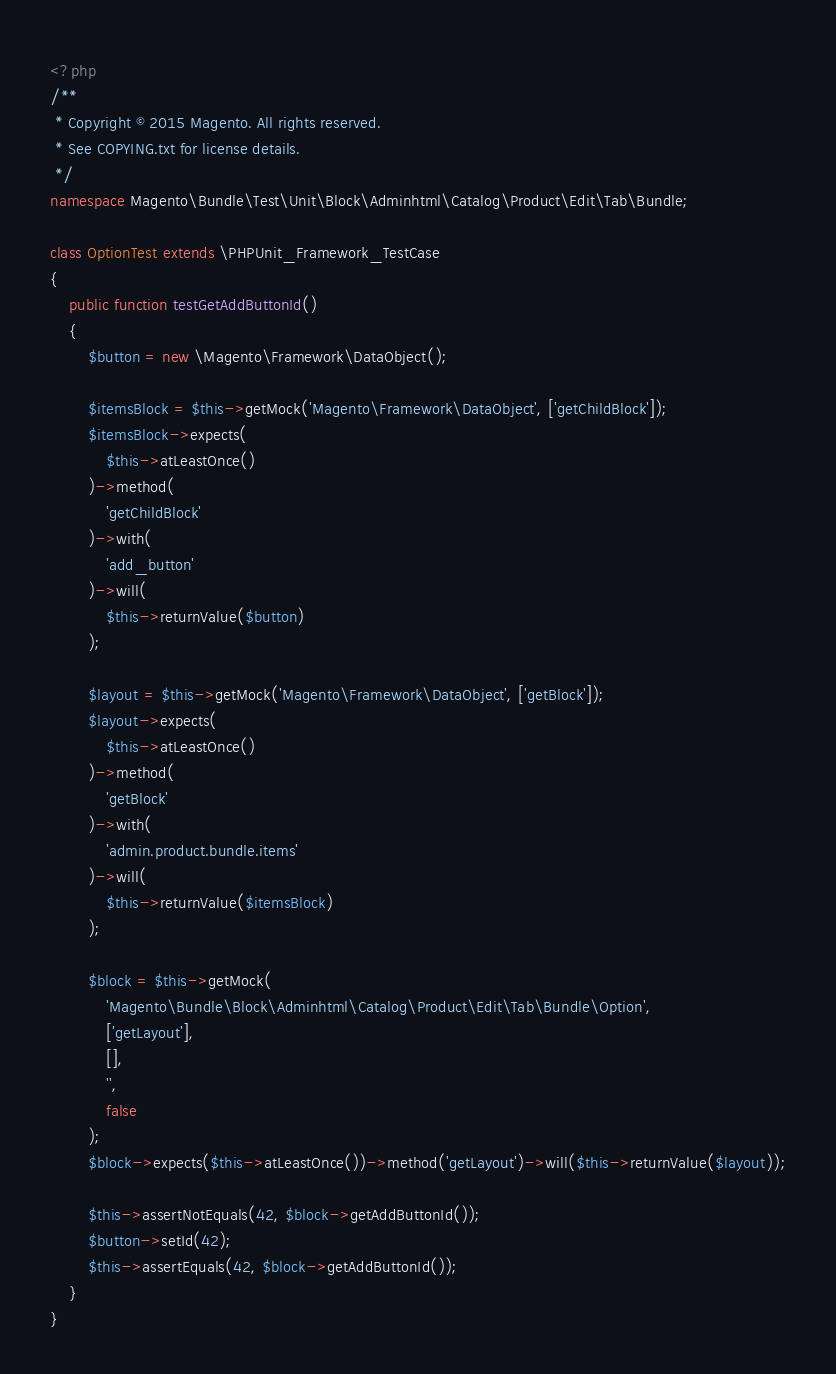Convert code to text. <code><loc_0><loc_0><loc_500><loc_500><_PHP_><?php
/**
 * Copyright © 2015 Magento. All rights reserved.
 * See COPYING.txt for license details.
 */
namespace Magento\Bundle\Test\Unit\Block\Adminhtml\Catalog\Product\Edit\Tab\Bundle;

class OptionTest extends \PHPUnit_Framework_TestCase
{
    public function testGetAddButtonId()
    {
        $button = new \Magento\Framework\DataObject();

        $itemsBlock = $this->getMock('Magento\Framework\DataObject', ['getChildBlock']);
        $itemsBlock->expects(
            $this->atLeastOnce()
        )->method(
            'getChildBlock'
        )->with(
            'add_button'
        )->will(
            $this->returnValue($button)
        );

        $layout = $this->getMock('Magento\Framework\DataObject', ['getBlock']);
        $layout->expects(
            $this->atLeastOnce()
        )->method(
            'getBlock'
        )->with(
            'admin.product.bundle.items'
        )->will(
            $this->returnValue($itemsBlock)
        );

        $block = $this->getMock(
            'Magento\Bundle\Block\Adminhtml\Catalog\Product\Edit\Tab\Bundle\Option',
            ['getLayout'],
            [],
            '',
            false
        );
        $block->expects($this->atLeastOnce())->method('getLayout')->will($this->returnValue($layout));

        $this->assertNotEquals(42, $block->getAddButtonId());
        $button->setId(42);
        $this->assertEquals(42, $block->getAddButtonId());
    }
}
</code> 